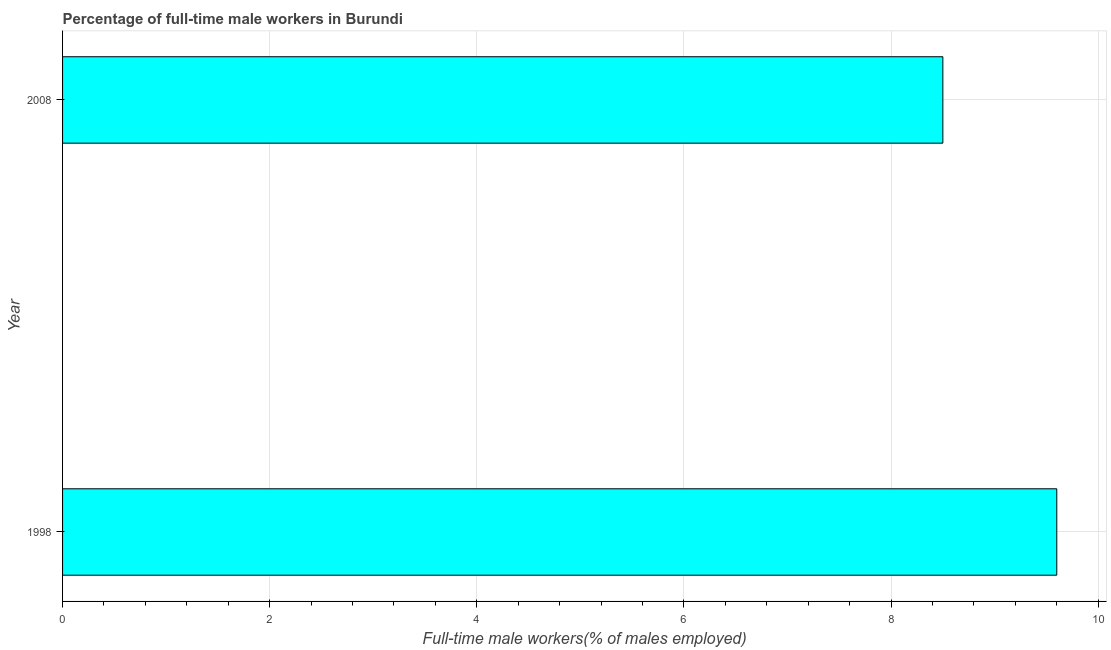Does the graph contain grids?
Give a very brief answer. Yes. What is the title of the graph?
Provide a short and direct response. Percentage of full-time male workers in Burundi. What is the label or title of the X-axis?
Your answer should be compact. Full-time male workers(% of males employed). What is the percentage of full-time male workers in 2008?
Your response must be concise. 8.5. Across all years, what is the maximum percentage of full-time male workers?
Ensure brevity in your answer.  9.6. Across all years, what is the minimum percentage of full-time male workers?
Give a very brief answer. 8.5. What is the sum of the percentage of full-time male workers?
Ensure brevity in your answer.  18.1. What is the average percentage of full-time male workers per year?
Give a very brief answer. 9.05. What is the median percentage of full-time male workers?
Keep it short and to the point. 9.05. In how many years, is the percentage of full-time male workers greater than 8.8 %?
Give a very brief answer. 1. Do a majority of the years between 1998 and 2008 (inclusive) have percentage of full-time male workers greater than 2 %?
Your answer should be very brief. Yes. What is the ratio of the percentage of full-time male workers in 1998 to that in 2008?
Provide a short and direct response. 1.13. Is the percentage of full-time male workers in 1998 less than that in 2008?
Offer a terse response. No. In how many years, is the percentage of full-time male workers greater than the average percentage of full-time male workers taken over all years?
Keep it short and to the point. 1. How many years are there in the graph?
Offer a terse response. 2. Are the values on the major ticks of X-axis written in scientific E-notation?
Make the answer very short. No. What is the Full-time male workers(% of males employed) in 1998?
Make the answer very short. 9.6. What is the Full-time male workers(% of males employed) in 2008?
Give a very brief answer. 8.5. What is the difference between the Full-time male workers(% of males employed) in 1998 and 2008?
Offer a terse response. 1.1. What is the ratio of the Full-time male workers(% of males employed) in 1998 to that in 2008?
Offer a terse response. 1.13. 